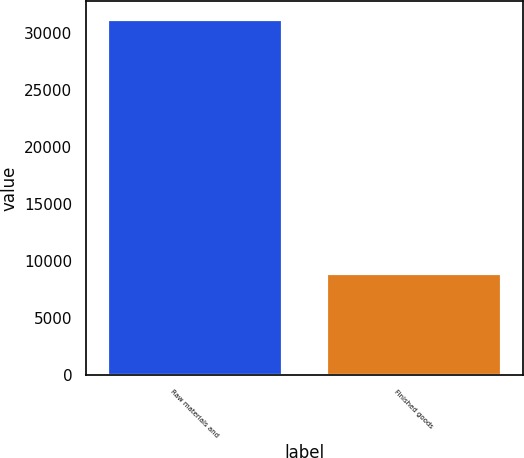Convert chart. <chart><loc_0><loc_0><loc_500><loc_500><bar_chart><fcel>Raw materials and<fcel>Finished goods<nl><fcel>31252<fcel>8922<nl></chart> 